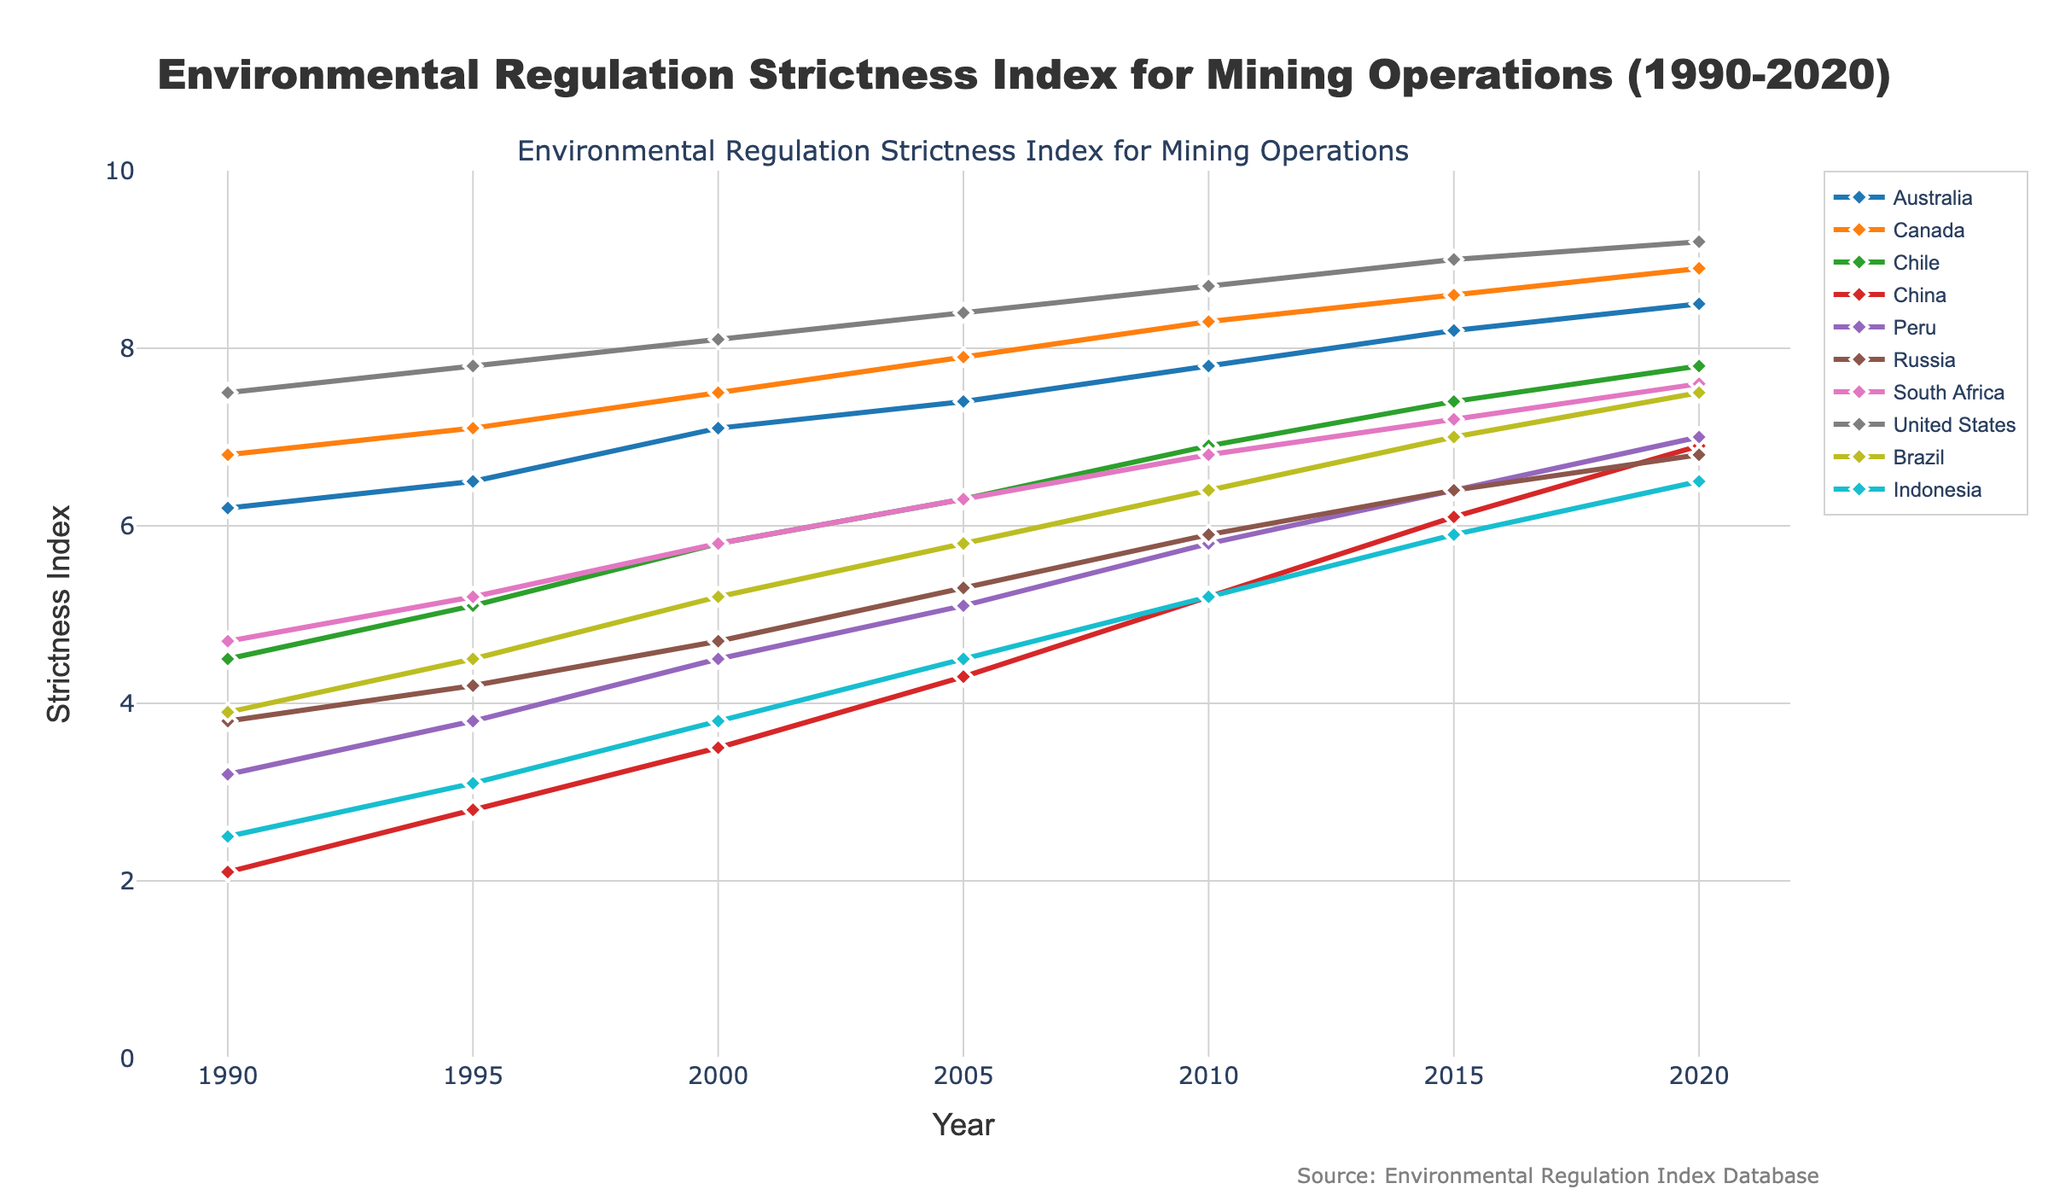Which country had the highest Environmental Regulation Strictness Index in 2020? The highest values in 2020 are represented by the peak points on the right side of the graph. The United States reaches the highest point at 9.2 on the index.
Answer: United States Which country showed the greatest overall increase in the Environmental Regulation Strictness Index from 1990 to 2020? Calculate the difference between the values in 2020 and 1990 for each country. China increased from 2.1 to 6.9, a difference of 4.8, which is the largest.
Answer: China What is the average Environmental Regulation Strictness Index for Canada over the period from 1990 to 2020? Add up Canada's index values for all the years and then divide by the number of points (7): (6.8 + 7.1 + 7.5 + 7.9 + 8.3 + 8.6 + 8.9)/7 = 7.73.
Answer: 7.73 By how much did the Environmental Regulation Strictness Index of Peru change from 2000 to 2020? Subtract the index value in 2000 from the value in 2020 for Peru: 7.0 - 4.5 = 2.5.
Answer: 2.5 Which two countries had the most similar Environmental Regulation Strictness Index in 2015? Look for the closest points in 2015. Russia (6.4) and Brazil (7.0) are the closest with a difference of 0.6.
Answer: Russia and Brazil What is the median value of the Environmental Regulation Strictness Index for South Africa over the period from 1990 to 2020? Sort South Africa's values and find the middle one: [4.7, 5.2, 5.8, 6.3, 6.8, 7.2, 7.6]. The median is 6.3.
Answer: 6.3 Which country had a stricter Environmental Regulation Index in 2010, China or Indonesia? Compare the points for China and Indonesia in 2010. China has an index of 5.2 while Indonesia has 5.2. Hence, they are equal.
Answer: Equal Identify the year when Australia’s Environmental Regulation Strictness Index surpassed 7 for the first time. Trace the line for Australia until it first crosses the value of 7. This occurs in the year 2000.
Answer: 2000 Compare the growth rates of Brazil and South Africa between 1990 and 2020. Which one had a higher growth rate? Calculate the differences (2020 value - 1990 value) for each country: Brazil (7.5 - 3.9 = 3.6), South Africa (7.6 - 4.7 = 2.9). Brazil has a higher growth rate.
Answer: Brazil How does the trend of the Environmental Regulation Strictness Index in Russia compare to that in Chile from 1995 to 2005? Compare the slopes of their lines between 1995 and 2005. Russia’s index increases steadily from 4.2 to 5.3, while Chile’s increases from 5.1 to 6.3. Both increase, but Chile’s growth is more steep.
Answer: Both increase, Chile’s is steeper 